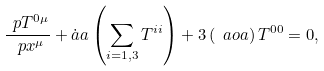<formula> <loc_0><loc_0><loc_500><loc_500>\frac { \ p T ^ { 0 \mu } } { \ p x ^ { \mu } } + \dot { a } a \left ( \sum _ { i = 1 , 3 } T ^ { i i } \right ) + 3 \left ( \ a o a \right ) T ^ { 0 0 } = 0 ,</formula> 